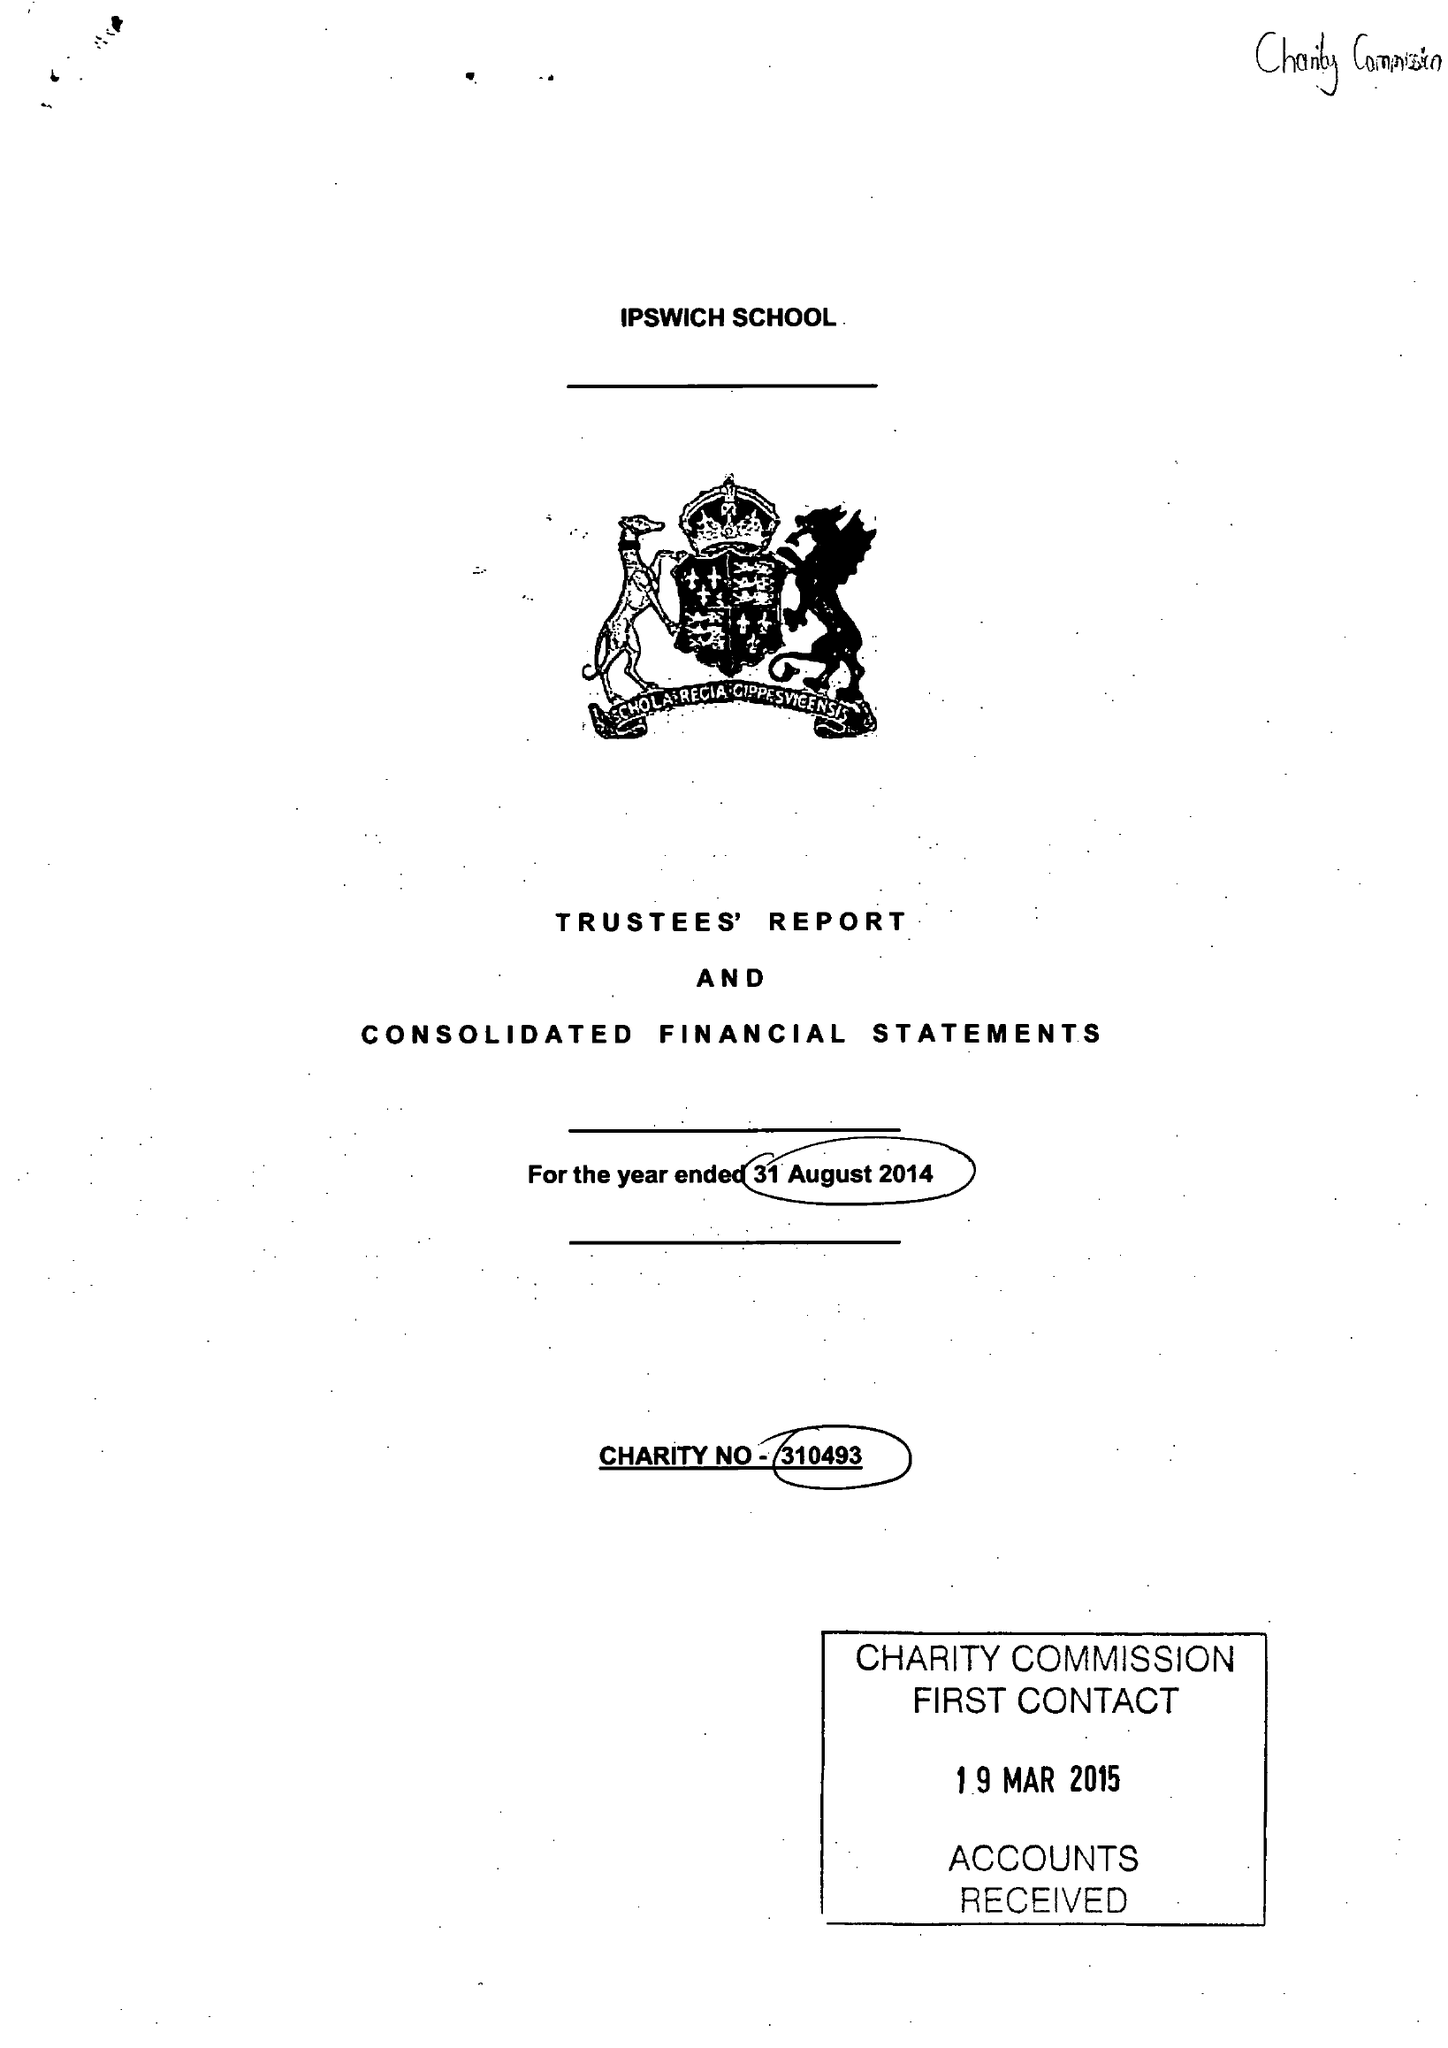What is the value for the charity_name?
Answer the question using a single word or phrase. Ipswich School 